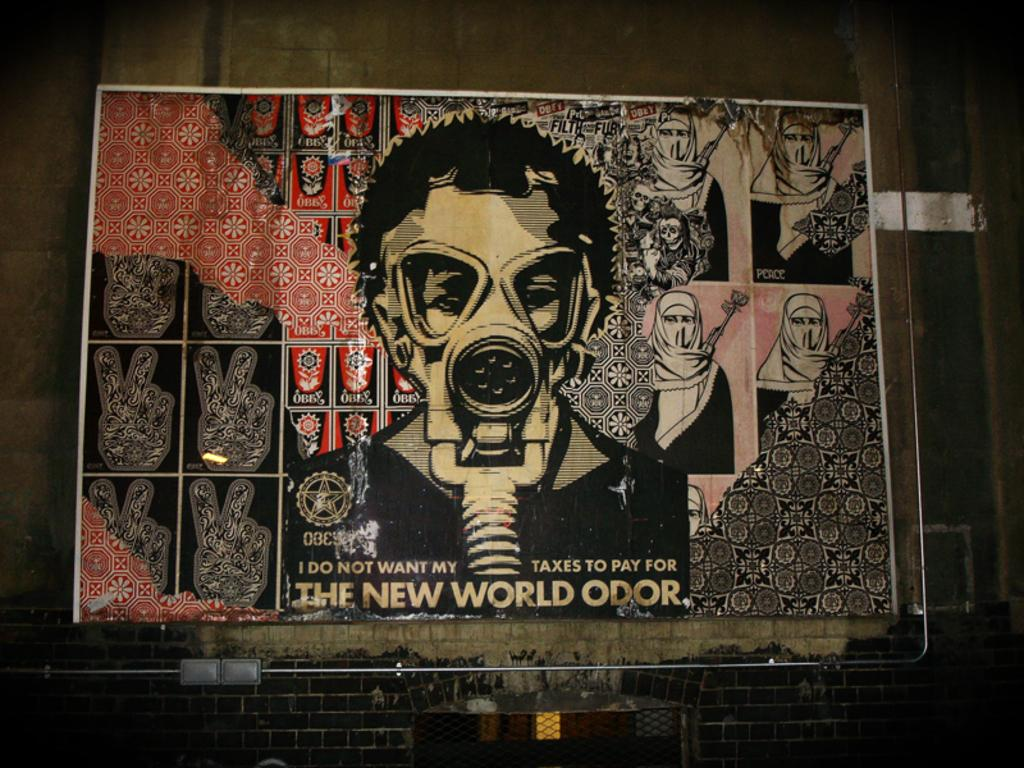What is the main subject in the image? There is a big poster in the image. Where is the poster located? The poster is on a wall. Is the hat in the image suitable for a beginner? There is no hat present in the image, so it cannot be determined if it is suitable for a beginner. 